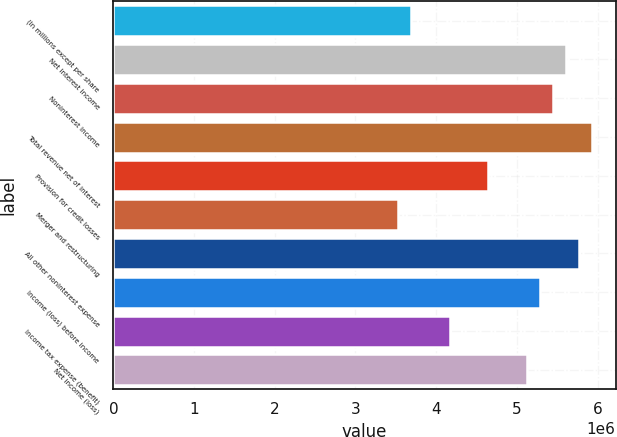<chart> <loc_0><loc_0><loc_500><loc_500><bar_chart><fcel>(In millions except per share<fcel>Net interest income<fcel>Noninterest income<fcel>Total revenue net of interest<fcel>Provision for credit losses<fcel>Merger and restructuring<fcel>All other noninterest expense<fcel>Income (loss) before income<fcel>Income tax expense (benefit)<fcel>Net income (loss)<nl><fcel>3.68477e+06<fcel>5.60725e+06<fcel>5.44705e+06<fcel>5.92767e+06<fcel>4.64601e+06<fcel>3.52456e+06<fcel>5.76746e+06<fcel>5.28684e+06<fcel>4.16539e+06<fcel>5.12663e+06<nl></chart> 